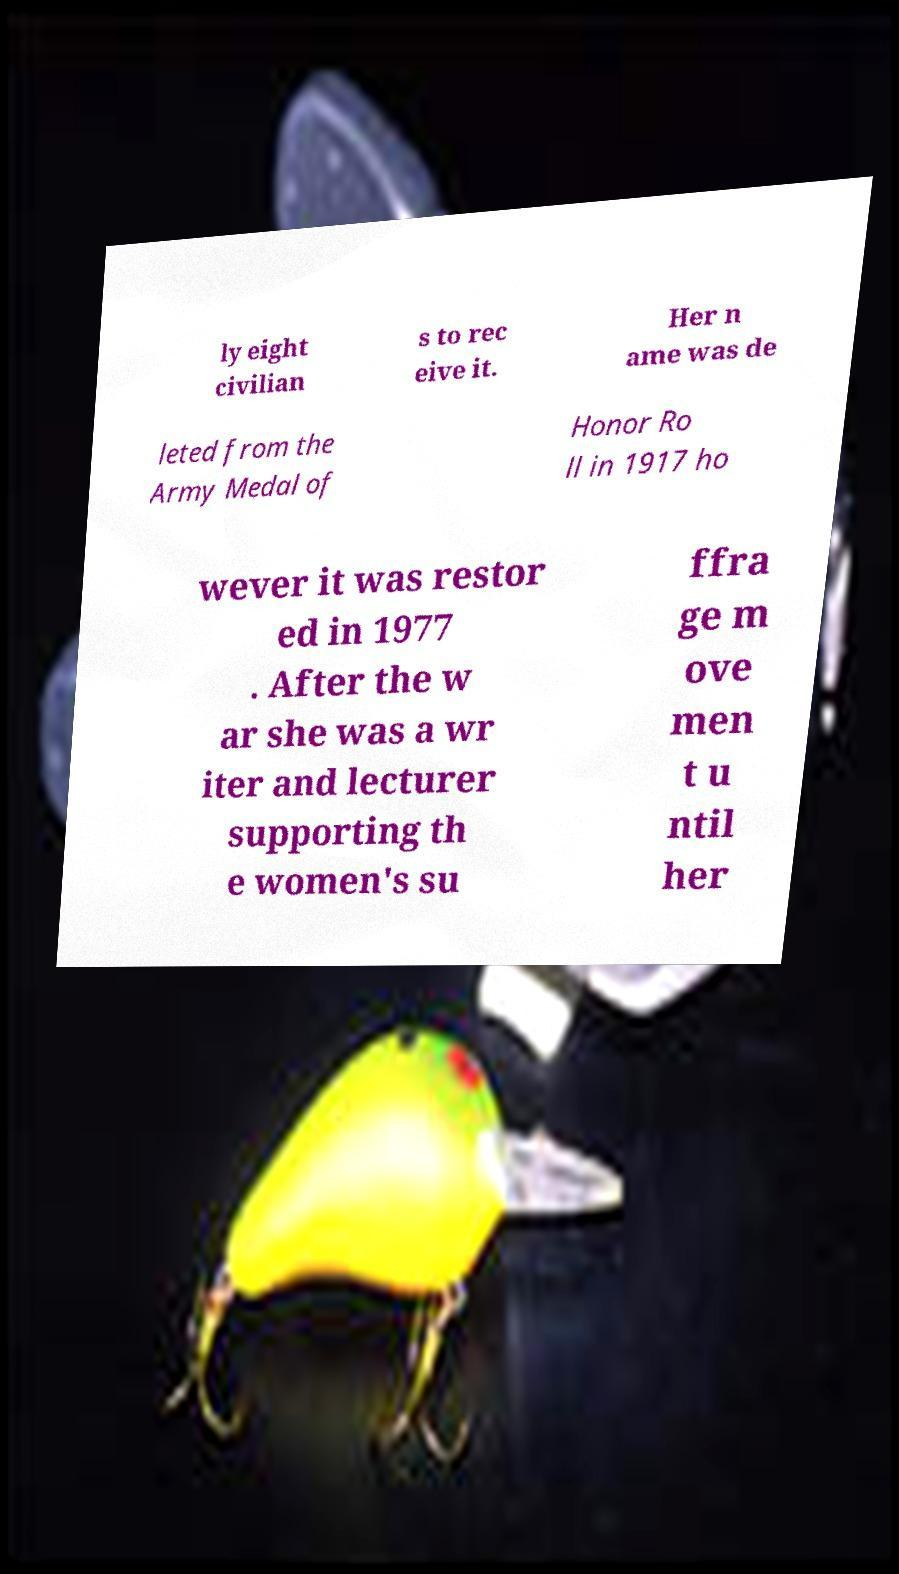What messages or text are displayed in this image? I need them in a readable, typed format. ly eight civilian s to rec eive it. Her n ame was de leted from the Army Medal of Honor Ro ll in 1917 ho wever it was restor ed in 1977 . After the w ar she was a wr iter and lecturer supporting th e women's su ffra ge m ove men t u ntil her 